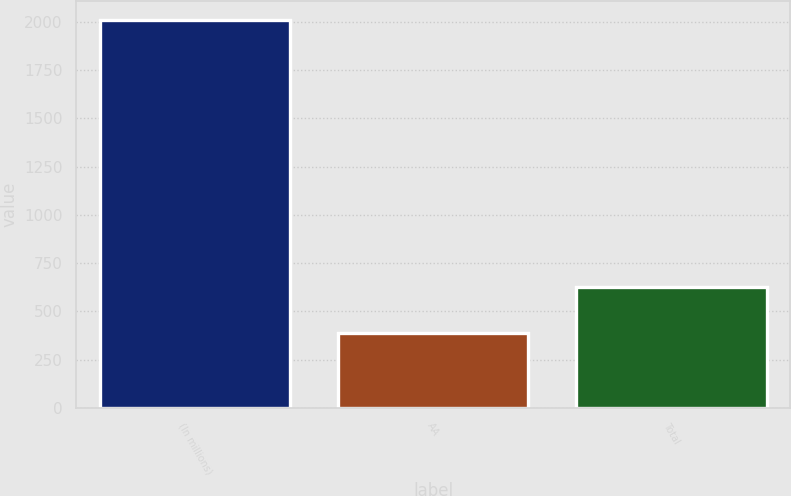Convert chart to OTSL. <chart><loc_0><loc_0><loc_500><loc_500><bar_chart><fcel>(In millions)<fcel>AA<fcel>Total<nl><fcel>2007<fcel>387<fcel>625<nl></chart> 